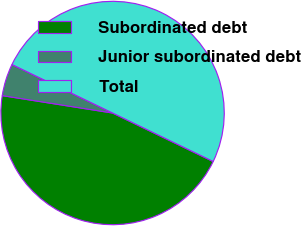Convert chart. <chart><loc_0><loc_0><loc_500><loc_500><pie_chart><fcel>Subordinated debt<fcel>Junior subordinated debt<fcel>Total<nl><fcel>45.34%<fcel>4.66%<fcel>50.0%<nl></chart> 